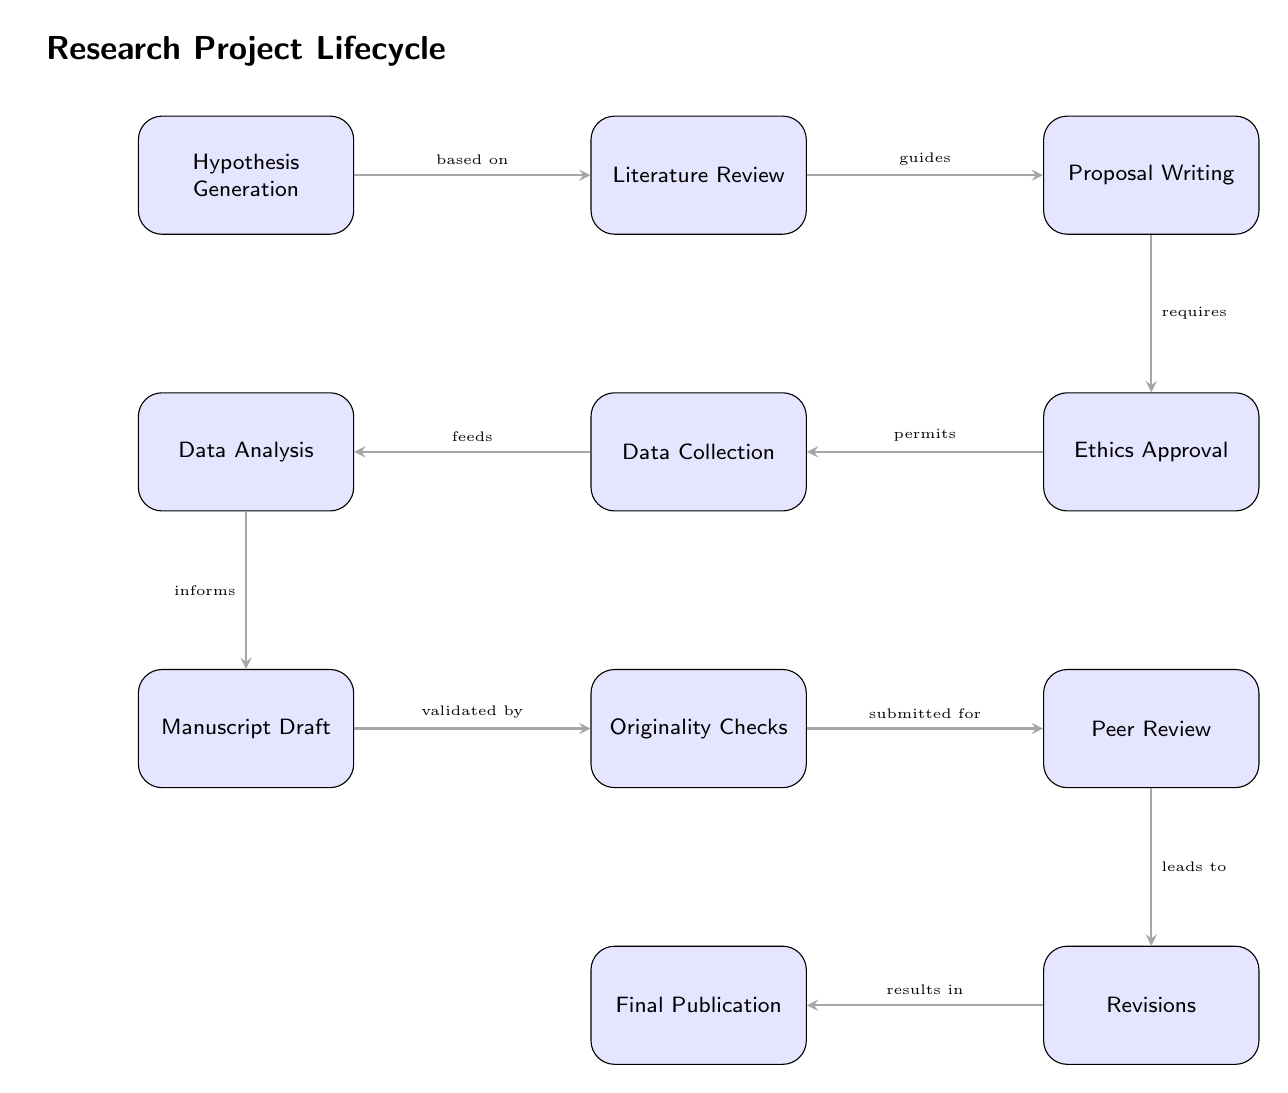What is the first step in the research project lifecycle? The diagram shows the first node as "Hypothesis Generation," indicating it is the initial step in the process.
Answer: Hypothesis Generation How many total steps are represented in the lifecycle? Counting the nodes in the diagram, there are eight distinct steps, including all the processes listed.
Answer: Eight What step requires approval before data collection? The diagram indicates that "Ethics Approval" must be obtained, which is necessary prior to the "Data Collection" phase.
Answer: Ethics Approval Which step follows the "Manuscript Draft" in the lifecycle? According to the flow in the diagram, the step that immediately comes after "Manuscript Draft" is "Originality Checks."
Answer: Originality Checks What action leads to "Revisions" in the process? The edge connecting "Peer Review" to "Revisions" shows that it is the process of peer evaluation that results in required revisions.
Answer: Peer Review What are the last two steps in the research process? The final two nodes at the bottom of the diagram are "Revisions" leading to "Final Publication," indicating the closure of the lifecycle.
Answer: Revisions, Final Publication What guides the proposal writing phase? The diagram notes that "Literature Review" serves as guidance for the "Proposal Writing," indicating its importance in shaping the proposal.
Answer: Literature Review How does data analysis inform the manuscript drafting? The flow from "Data Analysis" to "Manuscript Draft" indicates that the findings obtained from data analysis are used to inform and develop the draft of the manuscript.
Answer: Informs What precedes the "Data Analysis" phase? The direct connection shows that "Data Collection" is crucial since it must occur before any analysis can be performed.
Answer: Data Collection 